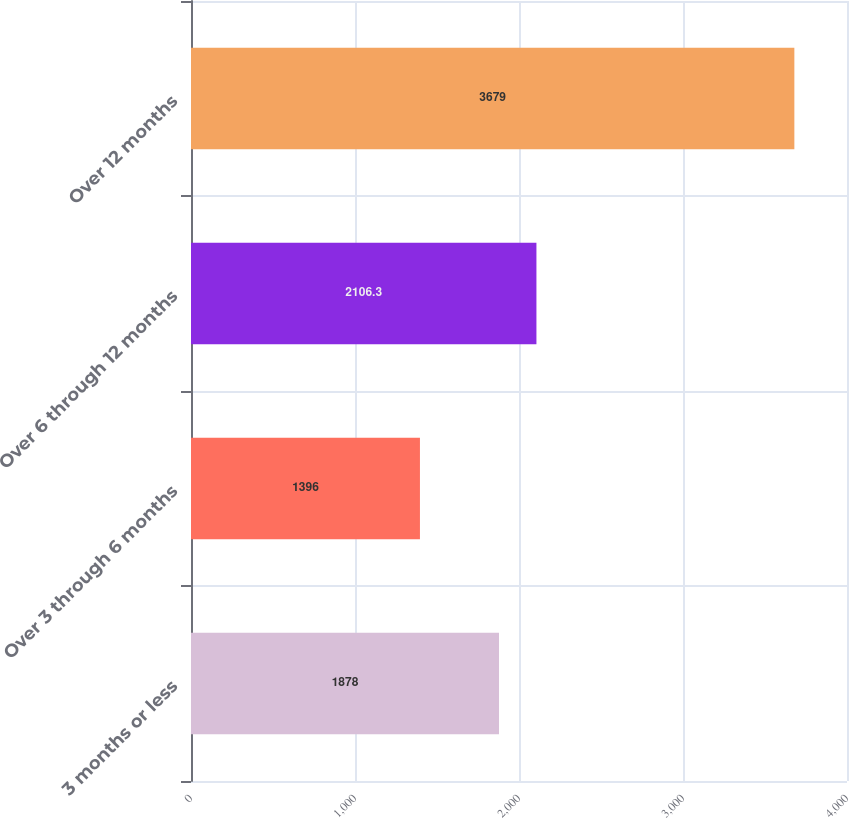<chart> <loc_0><loc_0><loc_500><loc_500><bar_chart><fcel>3 months or less<fcel>Over 3 through 6 months<fcel>Over 6 through 12 months<fcel>Over 12 months<nl><fcel>1878<fcel>1396<fcel>2106.3<fcel>3679<nl></chart> 